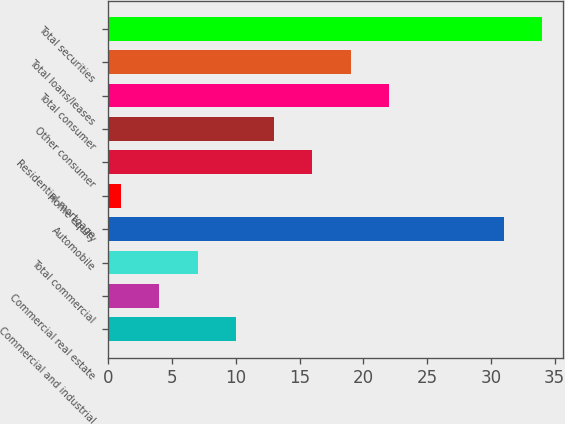Convert chart to OTSL. <chart><loc_0><loc_0><loc_500><loc_500><bar_chart><fcel>Commercial and industrial<fcel>Commercial real estate<fcel>Total commercial<fcel>Automobile<fcel>Home equity<fcel>Residential mortgage<fcel>Other consumer<fcel>Total consumer<fcel>Total loans/leases<fcel>Total securities<nl><fcel>10<fcel>4<fcel>7<fcel>31<fcel>1<fcel>16<fcel>13<fcel>22<fcel>19<fcel>34<nl></chart> 